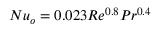<formula> <loc_0><loc_0><loc_500><loc_500>N u _ { o } = 0 . 0 2 3 R e ^ { 0 . 8 } P r ^ { 0 . 4 }</formula> 